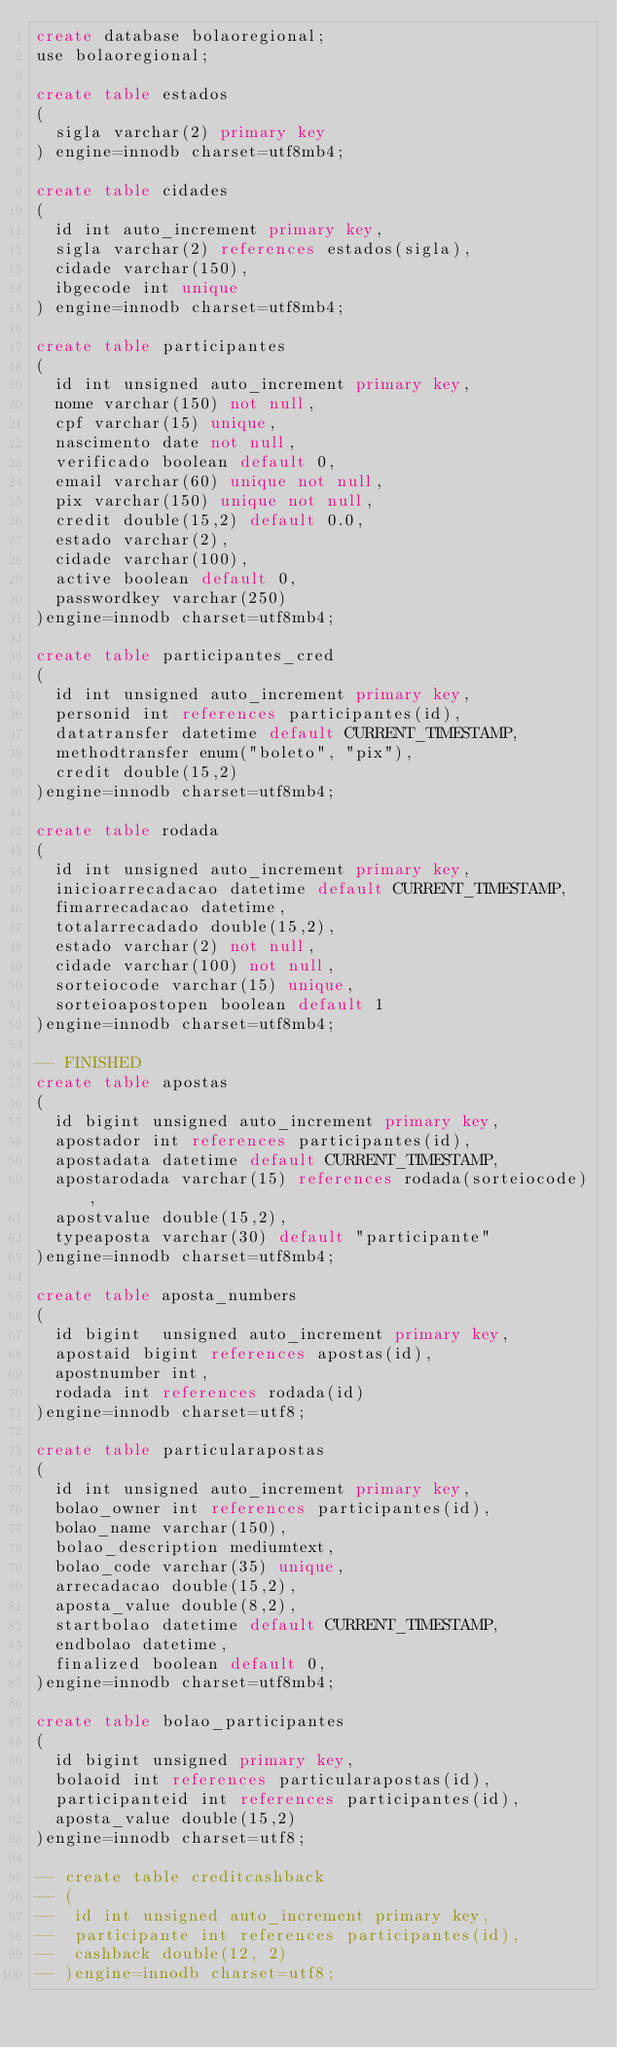<code> <loc_0><loc_0><loc_500><loc_500><_SQL_>create database bolaoregional;
use bolaoregional;

create table estados
(
	sigla varchar(2) primary key
) engine=innodb charset=utf8mb4;

create table cidades
(
	id int auto_increment primary key, 
	sigla varchar(2) references estados(sigla),
	cidade varchar(150),
	ibgecode int unique
) engine=innodb charset=utf8mb4;

create table participantes
(	
	id int unsigned auto_increment primary key,
	nome varchar(150) not null,
	cpf varchar(15) unique,
	nascimento date not null,
	verificado boolean default 0,
	email varchar(60) unique not null,
	pix varchar(150) unique not null,
	credit double(15,2) default 0.0,
	estado varchar(2),
	cidade varchar(100),
	active boolean default 0,
	passwordkey varchar(250)
)engine=innodb charset=utf8mb4;

create table participantes_cred
(	
	id int unsigned auto_increment primary key,
	personid int references participantes(id),
	datatransfer datetime default CURRENT_TIMESTAMP,
	methodtransfer enum("boleto", "pix"),
	credit double(15,2)
)engine=innodb charset=utf8mb4;

create table rodada
(	
	id int unsigned auto_increment primary key,
	inicioarrecadacao datetime default CURRENT_TIMESTAMP,
	fimarrecadacao datetime,
	totalarrecadado double(15,2),
	estado varchar(2) not null,
	cidade varchar(100) not null,
	sorteiocode varchar(15) unique,
	sorteioapostopen boolean default 1
)engine=innodb charset=utf8mb4;

-- FINISHED
create table apostas
(
	id bigint unsigned auto_increment primary key,
	apostador int references participantes(id),
	apostadata datetime default CURRENT_TIMESTAMP,
	apostarodada varchar(15) references rodada(sorteiocode), 
	apostvalue double(15,2),
	typeaposta varchar(30) default "participante"
)engine=innodb charset=utf8mb4;

create table aposta_numbers
(
	id bigint  unsigned auto_increment primary key,
	apostaid bigint references apostas(id),
	apostnumber int,
	rodada int references rodada(id)
)engine=innodb charset=utf8;

create table particularapostas
(
	id int unsigned auto_increment primary key,
	bolao_owner int references participantes(id),
	bolao_name varchar(150),
	bolao_description mediumtext,
	bolao_code varchar(35) unique,
	arrecadacao double(15,2),
	aposta_value double(8,2),
	startbolao datetime default CURRENT_TIMESTAMP,
	endbolao datetime,
	finalized boolean default 0,
)engine=innodb charset=utf8mb4;

create table bolao_participantes
(
	id bigint unsigned primary key,
	bolaoid int references particularapostas(id),
	participanteid int references participantes(id),
	aposta_value double(15,2)
)engine=innodb charset=utf8;

-- create table creditcashback
-- (
--	id int unsigned auto_increment primary key,
--	participante int references participantes(id),
--	cashback double(12, 2)
-- )engine=innodb charset=utf8;

</code> 